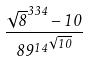<formula> <loc_0><loc_0><loc_500><loc_500>\frac { \sqrt { 8 } ^ { 3 3 4 } - 1 0 } { { 8 9 ^ { 1 4 } } ^ { \sqrt { 1 0 } } }</formula> 